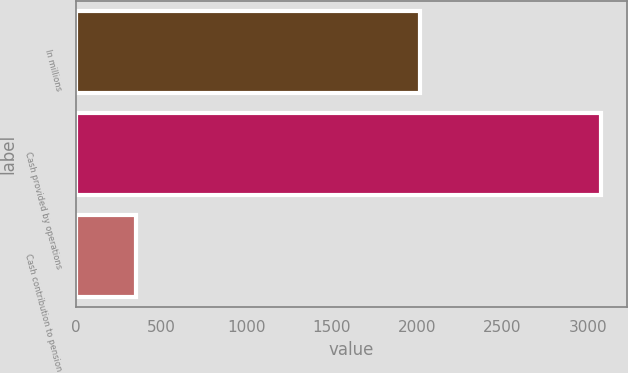Convert chart to OTSL. <chart><loc_0><loc_0><loc_500><loc_500><bar_chart><fcel>In millions<fcel>Cash provided by operations<fcel>Cash contribution to pension<nl><fcel>2014<fcel>3077<fcel>353<nl></chart> 